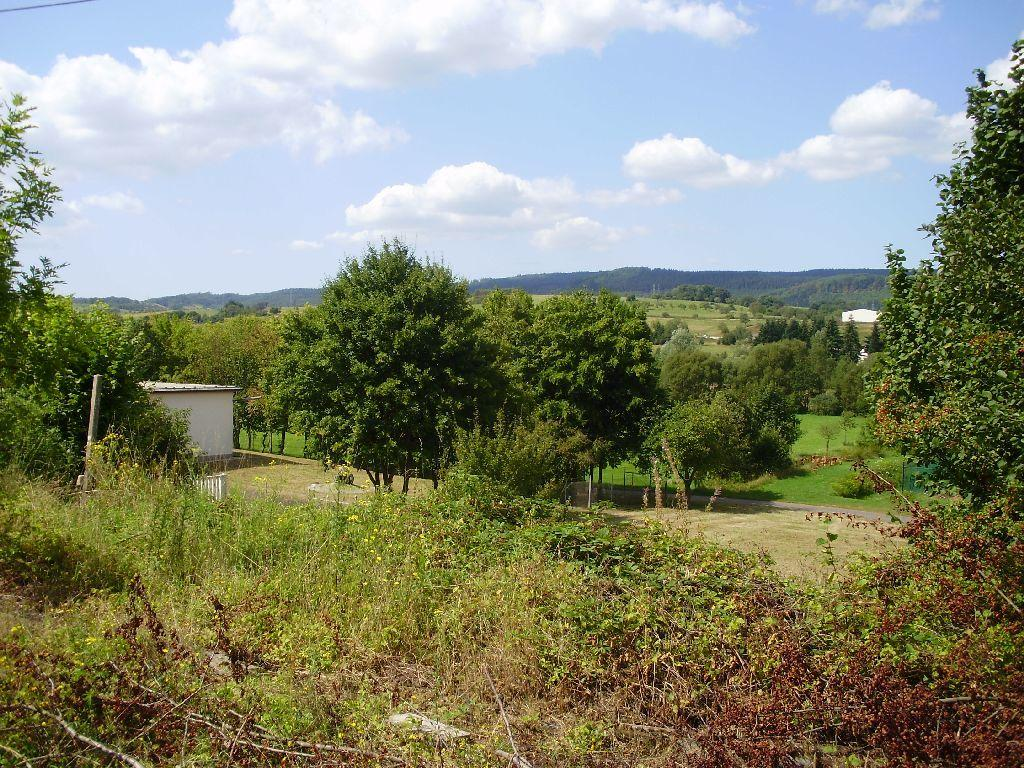What type of vegetation can be seen in the image? There are trees and plants in the image. What type of structure is present in the image? There is a house in the image. What type of natural landform is visible in the image? There are mountains in the image. What part of the natural environment is visible in the image? The sky is visible in the image. Can you tell me how many snakes are slithering on the ground in the image? There are no snakes present in the image. What type of wine is being served in the image? There is no wine present in the image. 